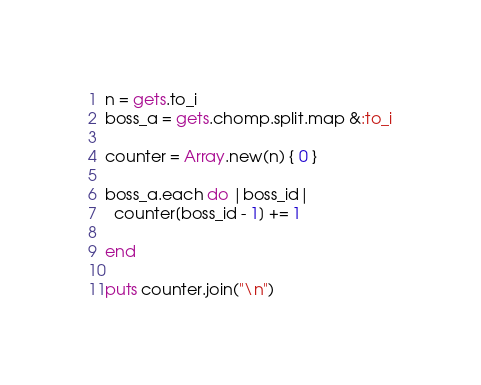<code> <loc_0><loc_0><loc_500><loc_500><_Ruby_>n = gets.to_i
boss_a = gets.chomp.split.map &:to_i

counter = Array.new(n) { 0 }

boss_a.each do |boss_id|
  counter[boss_id - 1] += 1

end

puts counter.join("\n")
</code> 